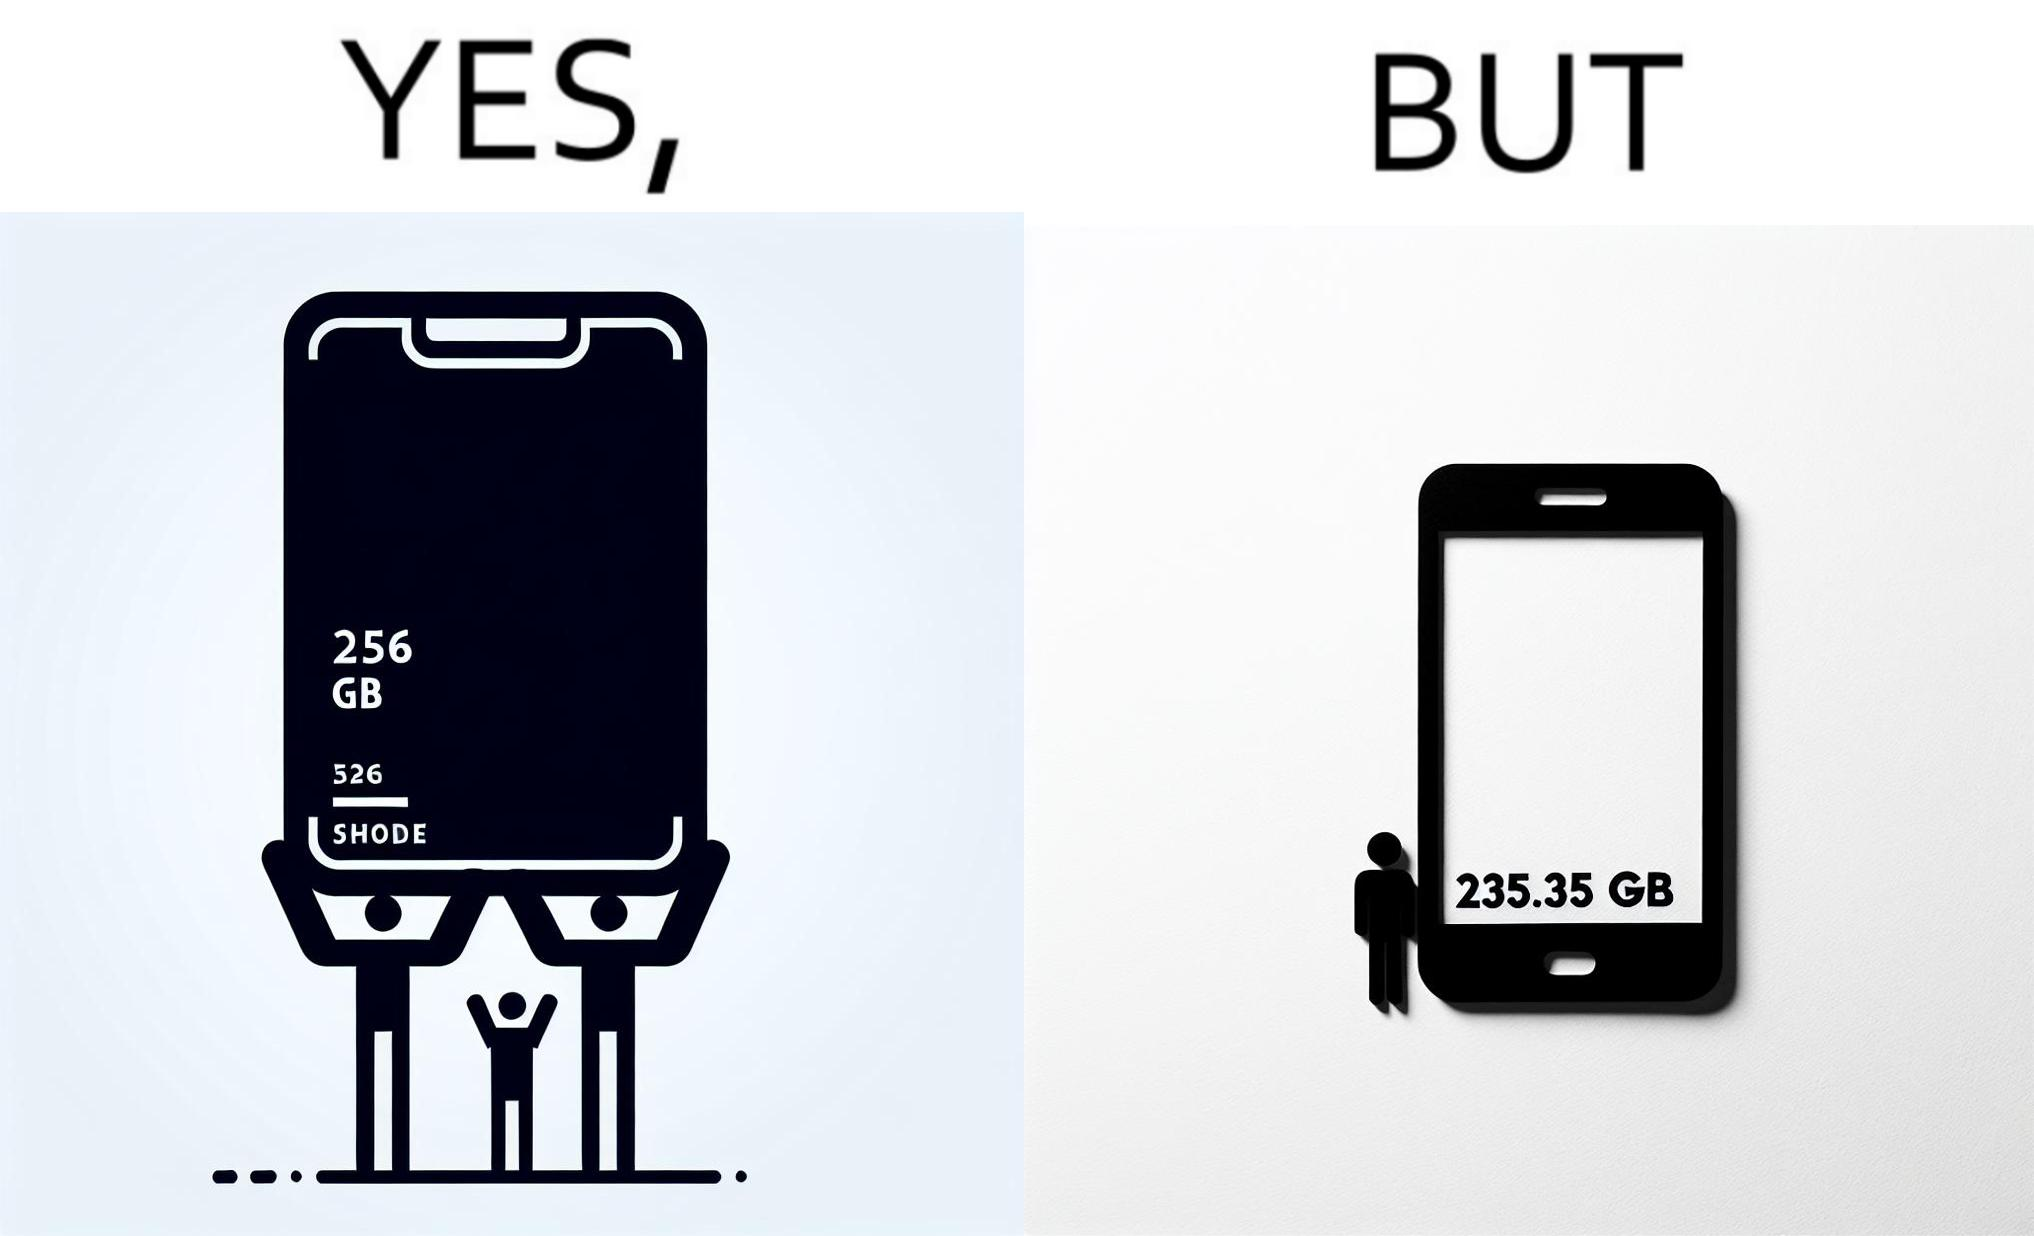Describe what you see in this image. The images are funny since they show how smartphone manufacturers advertise their smartphones to have a high internal storage space but in reality, the amount of space available to an user is considerably less due to pre-installed software 